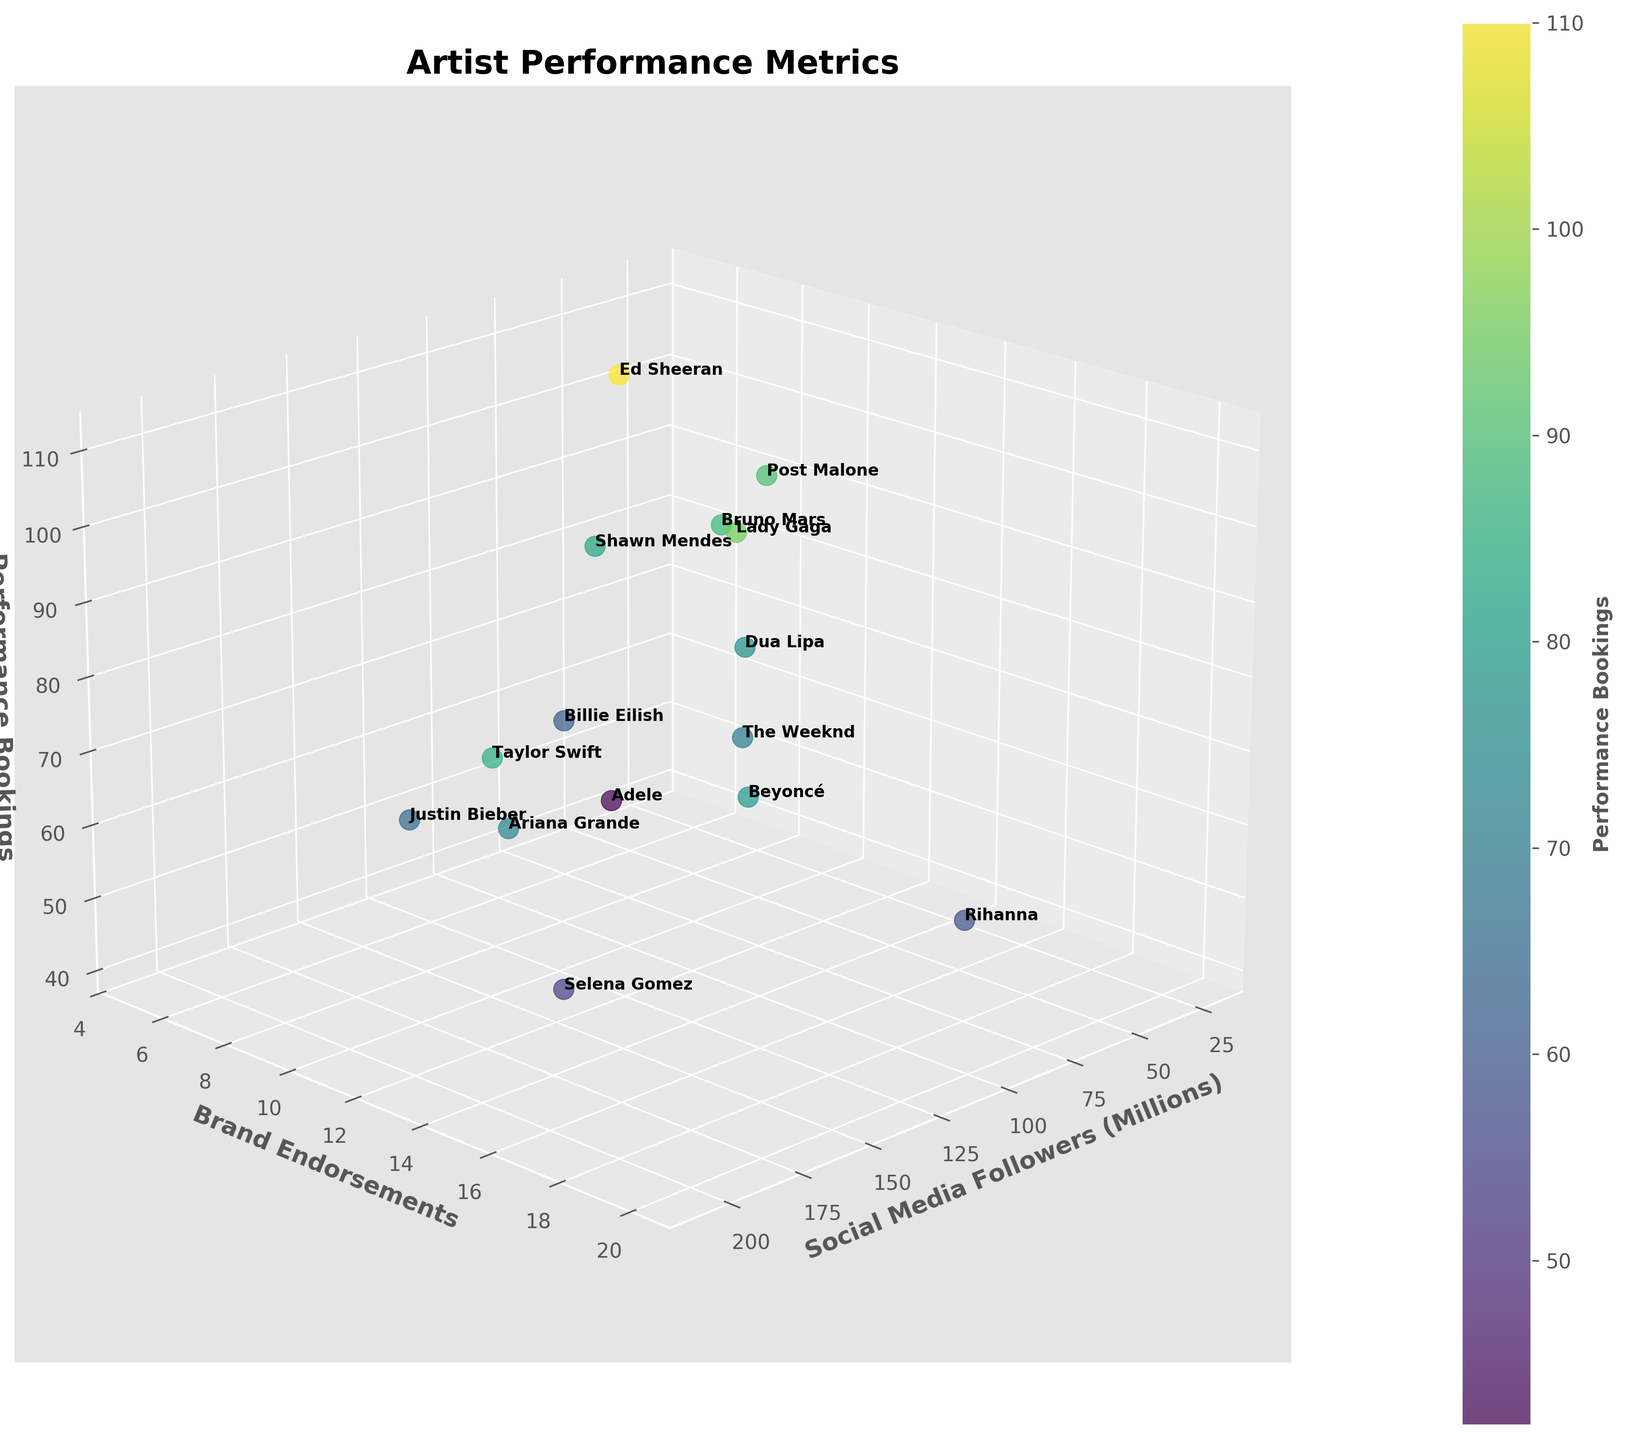How many artists are featured in the plot? Count the number of data points represented by individual markers or artist labels.
Answer: 15 Which artist has the highest number of social media followers? Locate the data point with the highest value on the 'Social Media Followers' axis and identify the corresponding artist label.
Answer: Taylor Swift What is the median number of brand endorsements among the artists? List all the values for brand endorsements, sort them, and find the middle value. The sorted values are [5, 6, 7, 8, 8, 9, 10, 11, 12, 13, 14, 15, 16, 18, 20]. The median value is the 8th value in the list.
Answer: 11 How does Ariana Grande's performance bookings compare to Beyoncé's? Identify the performance bookings (z-axis) for both Ariana Grande and Beyoncé. Ariana has 72 bookings while Beyoncé has 78. Compare these values.
Answer: Ariana Grande has fewer performance bookings than Beyoncé Which artist has both a relatively low number of social media followers and brand endorsements but high performance bookings? Look for an artist with low values on both the social media followers (x-axis) and brand endorsements (y-axis) but a high value on performance bookings (z-axis). Post Malone has 22 million followers and 8 endorsements but 90 bookings.
Answer: Post Malone What is the overall trend between the number of social media followers and performance bookings? Observe the general distribution of data points along the x-axis (social media followers) and z-axis (performance bookings). Are they generally increasing together, decreasing, or showing no clear trend?
Answer: No clear trend Who has more brand endorsements, The Weeknd or Lady Gaga? Compare the brand endorsements (y-axis) for The Weeknd (13) and Lady Gaga (12).
Answer: The Weeknd Out of all artists shown, which one has the smallest number of social media followers and how many are they? Find the data point with the smallest 'Social Media Followers' value and identify the corresponding artist. Post Malone has the smallest number of followers among the artists displayed (22 million).
Answer: Post Malone Among the three artists with the highest number of social media followers, who has the fewest performance bookings? Taylor Swift (207M), Ariana Grande (190M), and Selena Gomez (195M). Compare their performance bookings: Taylor Swift (85), Ariana Grande (72), Selena Gomez (55).
Answer: Selena Gomez 